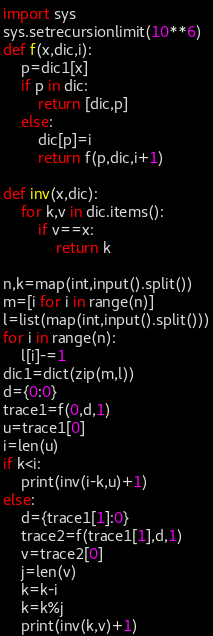<code> <loc_0><loc_0><loc_500><loc_500><_Python_>import sys
sys.setrecursionlimit(10**6)
def f(x,dic,i):
    p=dic1[x]
    if p in dic:
        return [dic,p]
    else:
        dic[p]=i
        return f(p,dic,i+1)

def inv(x,dic):
    for k,v in dic.items():
        if v==x:
            return k

n,k=map(int,input().split())
m=[i for i in range(n)]
l=list(map(int,input().split()))
for i in range(n):
    l[i]-=1
dic1=dict(zip(m,l))
d={0:0}
trace1=f(0,d,1)
u=trace1[0]
i=len(u)
if k<i:
    print(inv(i-k,u)+1)
else:
    d={trace1[1]:0}
    trace2=f(trace1[1],d,1)
    v=trace2[0]
    j=len(v)
    k=k-i
    k=k%j
    print(inv(k,v)+1)
</code> 